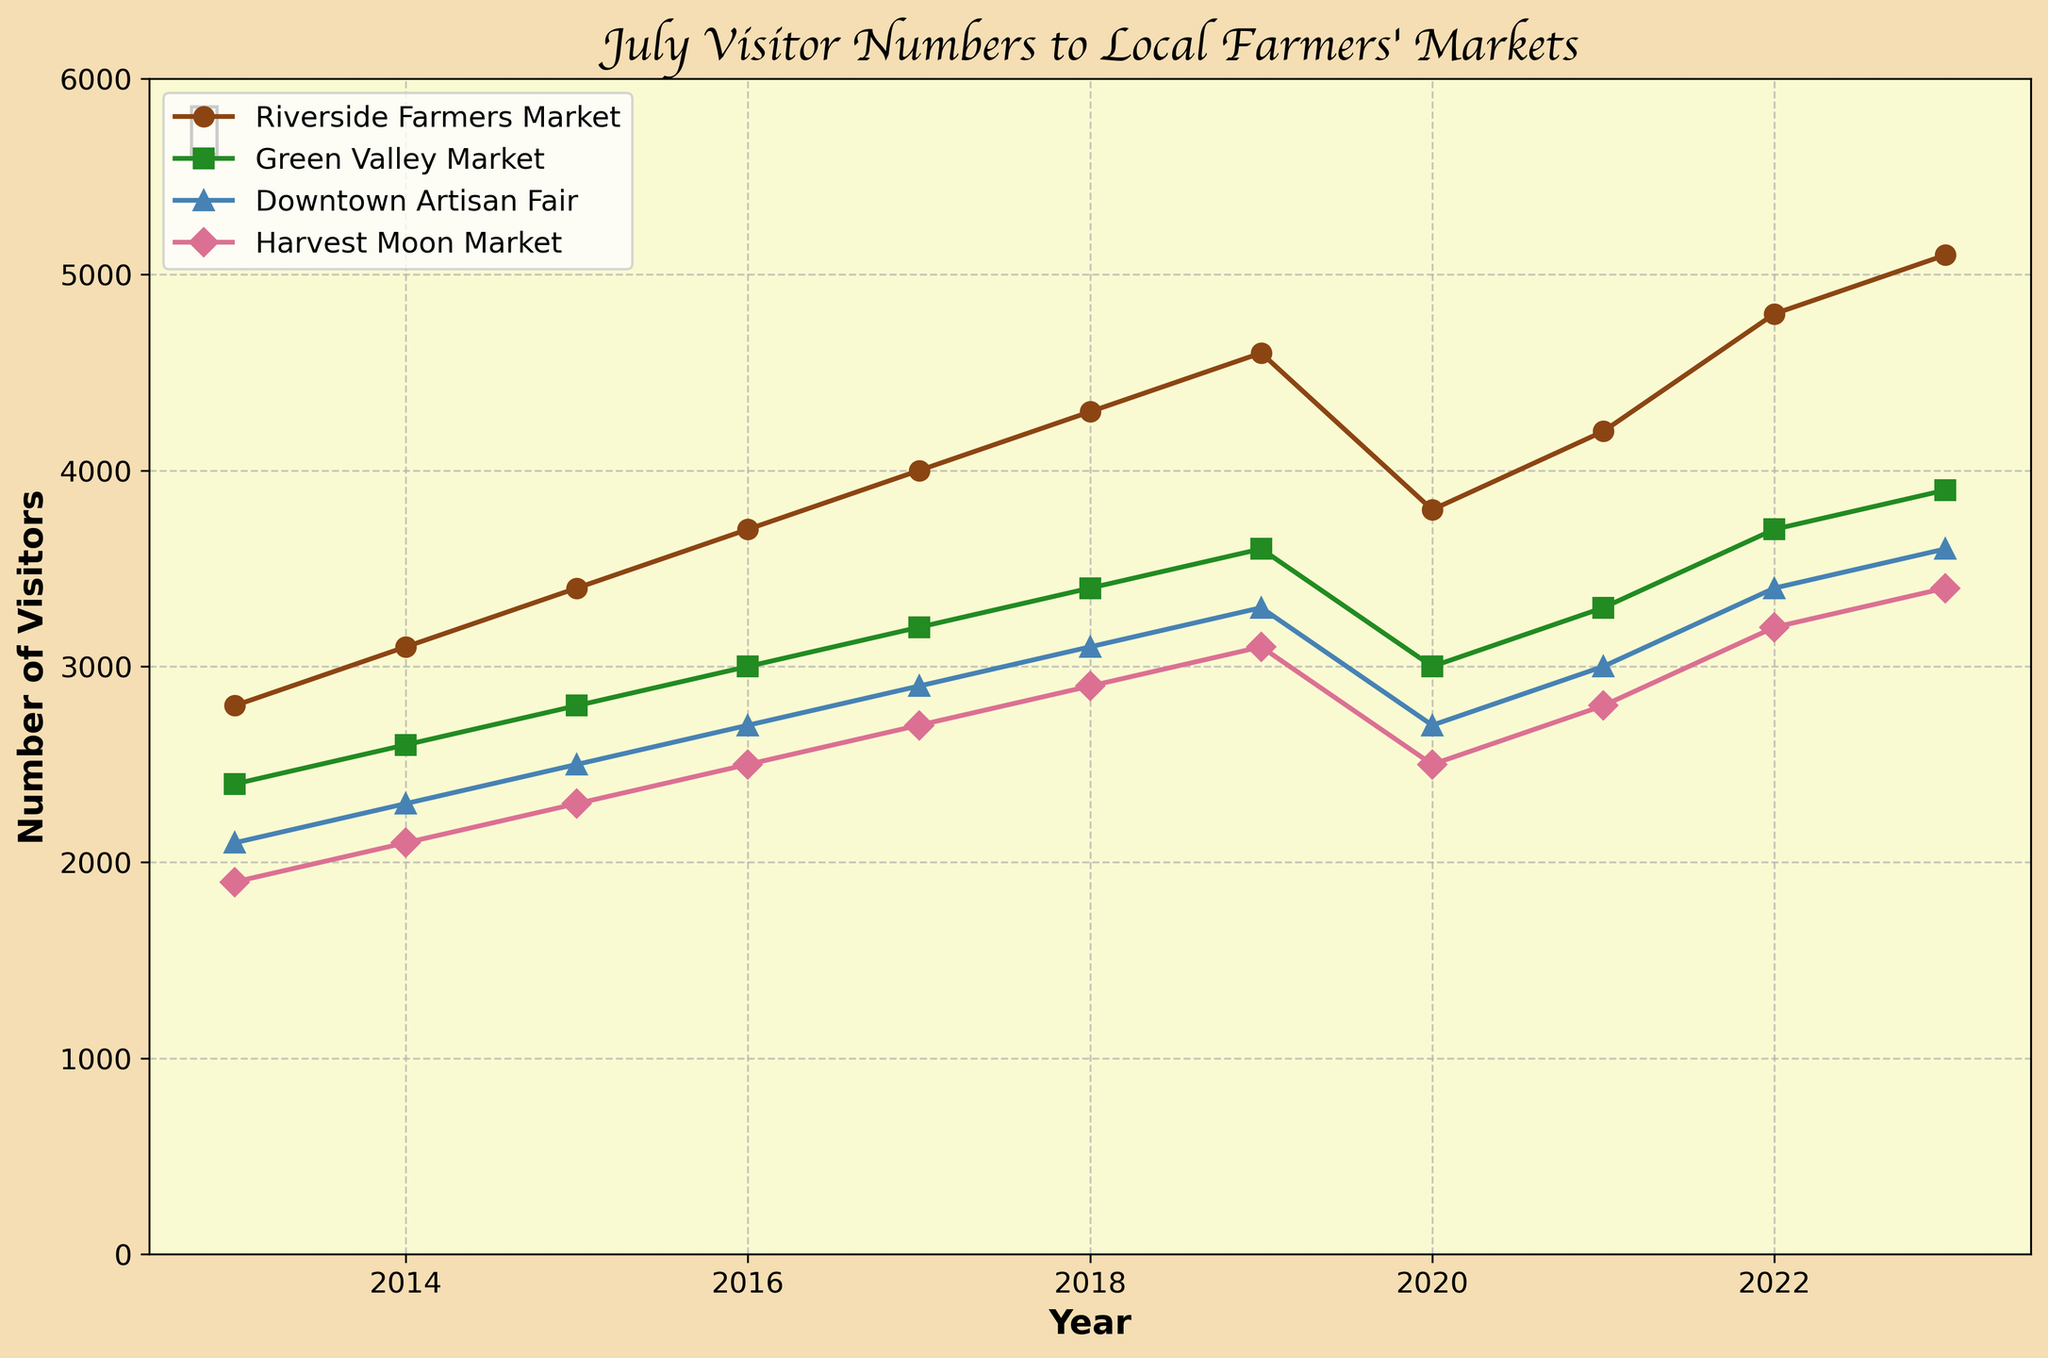What trend do you notice in the number of visitors to the Riverside Farmers Market over the years? The number of visitors to the Riverside Farmers Market has been steadily increasing each July from 2013 to 2023. Observing the line for Riverside Farmers Market, it's clear that it ascends consistently each year, starting from 2800 in 2013 to 5100 in 2023.
Answer: A consistent increase Which market saw the highest number of visitors in July 2023? The line chart indicates that the Riverside Farmers Market has the highest number of visitors in July 2023. The value of Riverside's line is at the top most at the year 2023, showing 5100 visitors.
Answer: Riverside Farmers Market How did visitor numbers in July 2020 compare between Riverside Farmers Market and Harvest Moon Market? To compare the visitor numbers, we look at the points in 2020 for both markets. Riverside Farmers Market shows around 3800 visitors while Harvest Moon Market shows around 2500 visitors.
Answer: Riverside had more visitors in July 2020 Which market had the most significant drop in visitors from July 2019 to July 2020? Observing the slopes between these years, the Riverside Farmers Market's line shows the most significant drop. It went from around 4600 visitors in 2019 to around 3800 in 2020, making it a drop of about 800 visitors. This is larger than the drops shown by the other markets.
Answer: Riverside Farmers Market In July 2022, what was the average number of visitors across all four markets? Summing up visitors for each market in July 2022: Riverside Farmers Market (4800), Green Valley Market (3700), Downtown Artisan Fair (3400), and Harvest Moon Market (3200). The total is 15100. Dividing this by 4 gives us the average: 15100/4 = 3775.
Answer: 3775 Between July 2018 and July 2019, which market saw the most significant increase in visitors? By comparing the difference between visitor numbers in July 2018 and July 2019 for each market, Riverside Farmers Market had an increase from 4300 to 4600, which is an increase of 300 visitors. This is the largest increase compared to the other markets.
Answer: Riverside Farmers Market What is the difference in visitors between the Green Valley Market and Downtown Artisan Fair in July 2023? To find the difference, subtract the number of visitors of Downtown Artisan Fair (3600) from Green Valley Market (3900). The calculation is 3900 - 3600 = 300.
Answer: 300 What was the total number of visitors for all markets in July 2015? Summing up the visitors for each market in July 2015: Riverside Farmers Market (3400), Green Valley Market (2800), Downtown Artisan Fair (2500), and Harvest Moon Market (2300). The total number of visitors is 3400 + 2800 + 2500 + 2300 = 11000.
Answer: 11000 